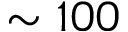<formula> <loc_0><loc_0><loc_500><loc_500>\sim 1 0 0</formula> 